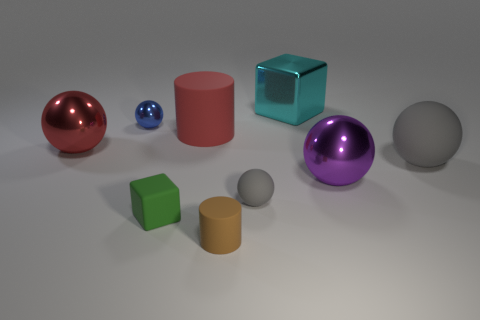Subtract all spheres. How many objects are left? 4 Subtract all blue balls. How many balls are left? 4 Subtract all big purple spheres. How many spheres are left? 4 Subtract 0 blue cylinders. How many objects are left? 9 Subtract 2 cylinders. How many cylinders are left? 0 Subtract all red spheres. Subtract all brown blocks. How many spheres are left? 4 Subtract all cyan cylinders. How many yellow spheres are left? 0 Subtract all yellow blocks. Subtract all brown cylinders. How many objects are left? 8 Add 7 small green matte things. How many small green matte things are left? 8 Add 1 small brown cylinders. How many small brown cylinders exist? 2 